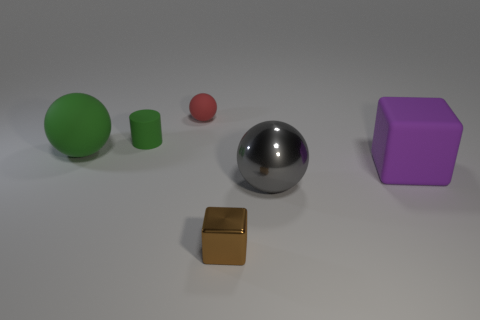Is the number of tiny blocks that are in front of the big green matte sphere greater than the number of small brown metallic balls?
Give a very brief answer. Yes. Are there any big spheres made of the same material as the tiny brown block?
Make the answer very short. Yes. Do the thing that is left of the tiny cylinder and the purple matte thing have the same shape?
Ensure brevity in your answer.  No. There is a large rubber thing that is to the left of the shiny object that is in front of the gray sphere; what number of large gray spheres are on the left side of it?
Offer a very short reply. 0. Is the number of large metallic balls that are behind the gray shiny sphere less than the number of big matte blocks on the right side of the small matte cylinder?
Keep it short and to the point. Yes. There is another large object that is the same shape as the big gray object; what is its color?
Keep it short and to the point. Green. The purple rubber cube is what size?
Make the answer very short. Large. What number of red matte things have the same size as the purple matte thing?
Keep it short and to the point. 0. Do the tiny cylinder and the large matte ball have the same color?
Your response must be concise. Yes. Is the material of the big thing behind the large purple matte thing the same as the cube right of the gray metallic object?
Give a very brief answer. Yes. 